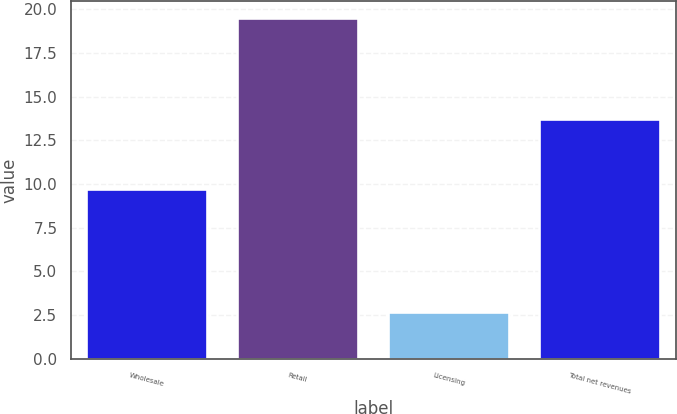Convert chart to OTSL. <chart><loc_0><loc_0><loc_500><loc_500><bar_chart><fcel>Wholesale<fcel>Retail<fcel>Licensing<fcel>Total net revenues<nl><fcel>9.7<fcel>19.5<fcel>2.7<fcel>13.7<nl></chart> 